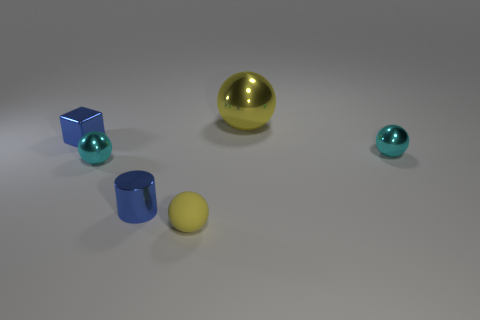Which object in the image appears to be the largest, and what could its size suggest about its importance or function? The largest object in the image is the big golden sphere. Its size might suggest that it plays a prominent role or holds significance in this setting, possibly as a central focal point or as a key element within an arrangement or a collection. 